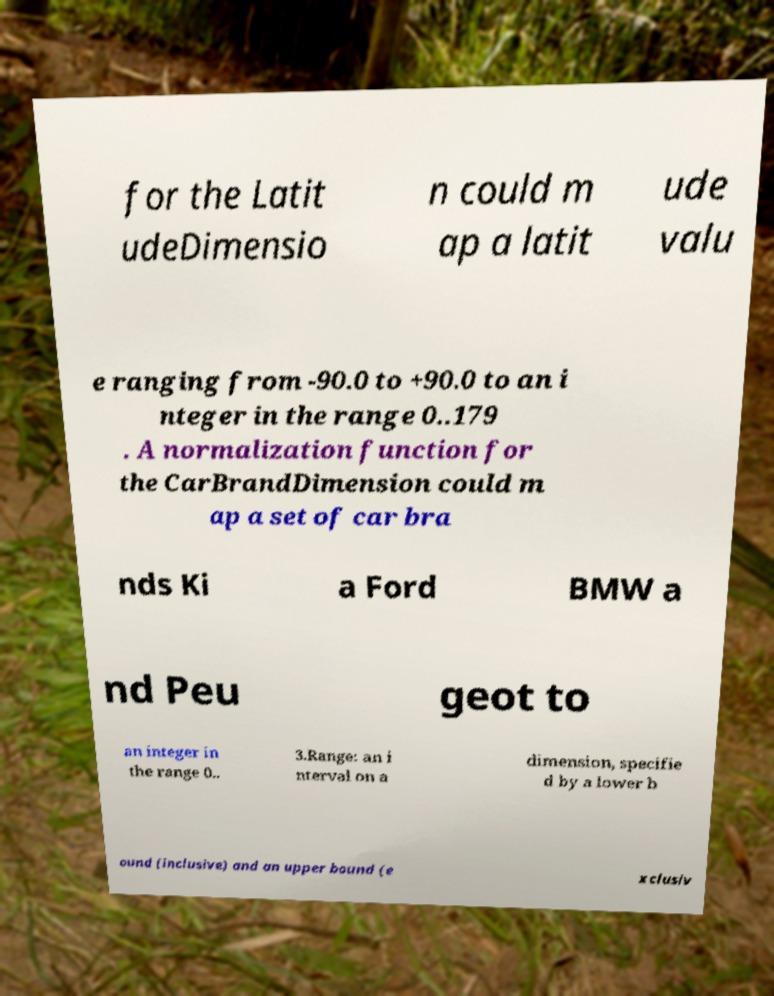For documentation purposes, I need the text within this image transcribed. Could you provide that? for the Latit udeDimensio n could m ap a latit ude valu e ranging from -90.0 to +90.0 to an i nteger in the range 0..179 . A normalization function for the CarBrandDimension could m ap a set of car bra nds Ki a Ford BMW a nd Peu geot to an integer in the range 0.. 3.Range: an i nterval on a dimension, specifie d by a lower b ound (inclusive) and an upper bound (e xclusiv 